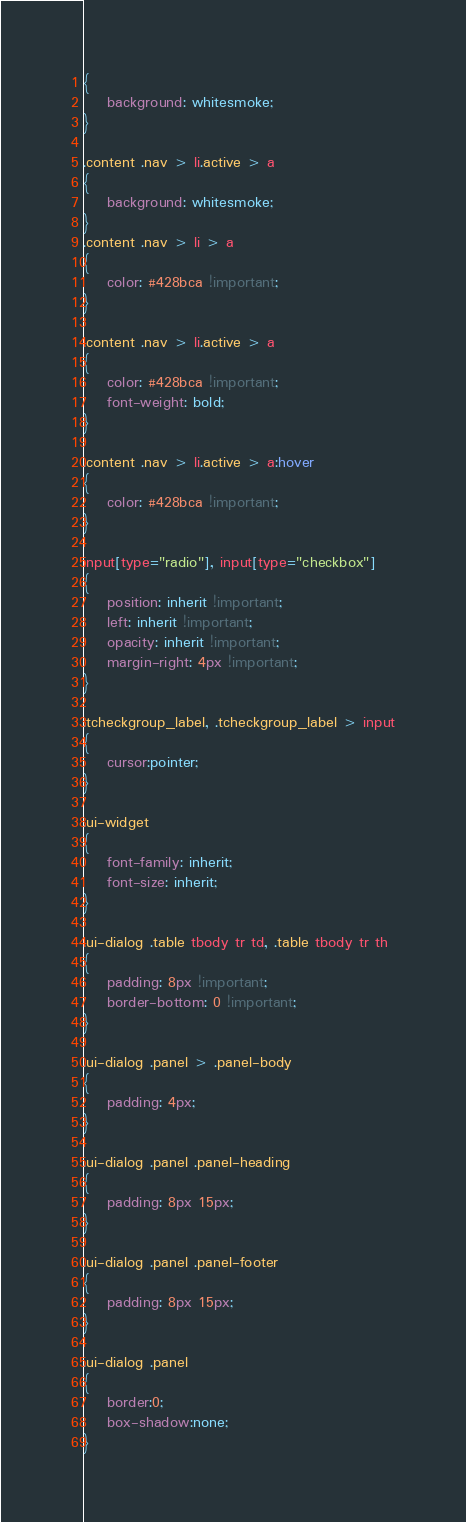<code> <loc_0><loc_0><loc_500><loc_500><_CSS_>{
    background: whitesmoke;
}

.content .nav > li.active > a
{
    background: whitesmoke;
}
.content .nav > li > a
{
    color: #428bca !important;
}

.content .nav > li.active > a
{
    color: #428bca !important;
    font-weight: bold;
}

.content .nav > li.active > a:hover
{
    color: #428bca !important;
}

input[type="radio"], input[type="checkbox"]
{
    position: inherit !important;
    left: inherit !important;
    opacity: inherit !important;
    margin-right: 4px !important;
}

.tcheckgroup_label, .tcheckgroup_label > input
{
    cursor:pointer;
}

.ui-widget
{
    font-family: inherit;
    font-size: inherit;
}

.ui-dialog .table tbody tr td, .table tbody tr th
{
    padding: 8px !important;
    border-bottom: 0 !important;
}

.ui-dialog .panel > .panel-body
{
    padding: 4px;
}

.ui-dialog .panel .panel-heading
{
    padding: 8px 15px;
}

.ui-dialog .panel .panel-footer
{
    padding: 8px 15px;
}

.ui-dialog .panel
{
    border:0;
    box-shadow:none;
}
</code> 